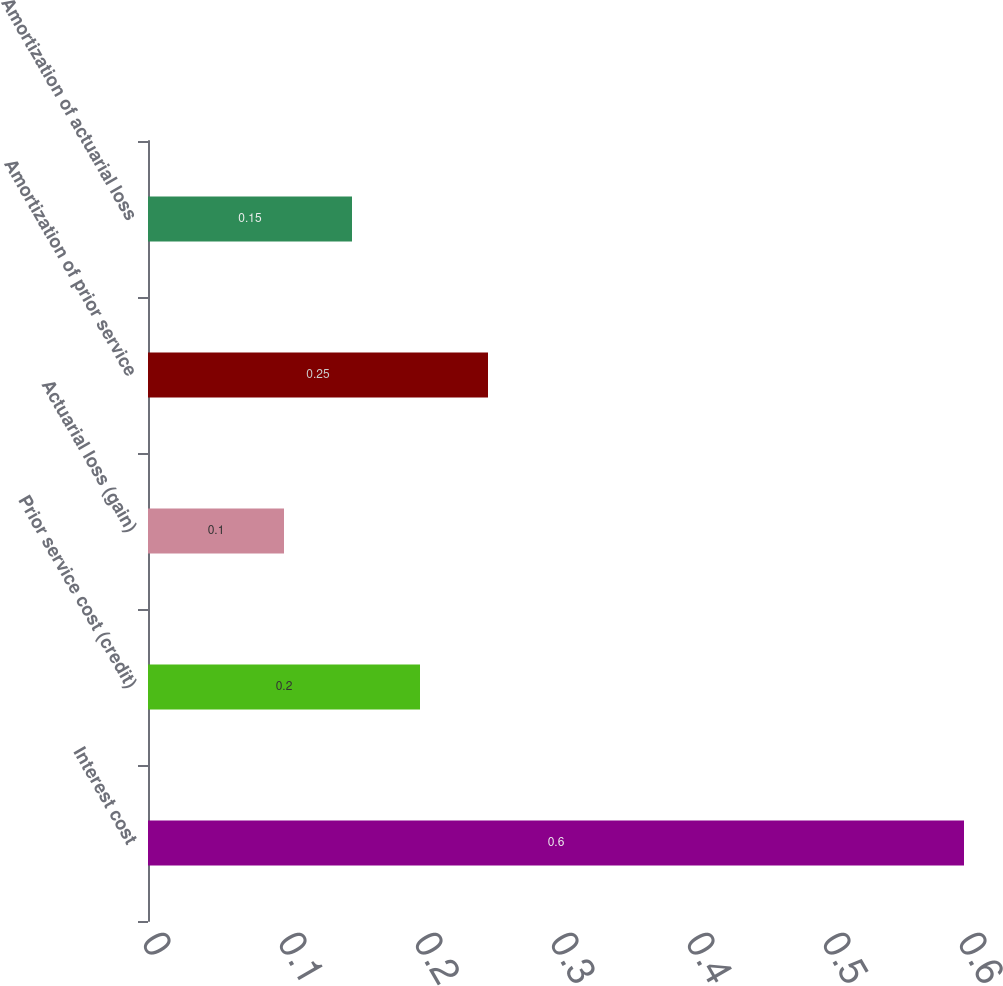Convert chart. <chart><loc_0><loc_0><loc_500><loc_500><bar_chart><fcel>Interest cost<fcel>Prior service cost (credit)<fcel>Actuarial loss (gain)<fcel>Amortization of prior service<fcel>Amortization of actuarial loss<nl><fcel>0.6<fcel>0.2<fcel>0.1<fcel>0.25<fcel>0.15<nl></chart> 